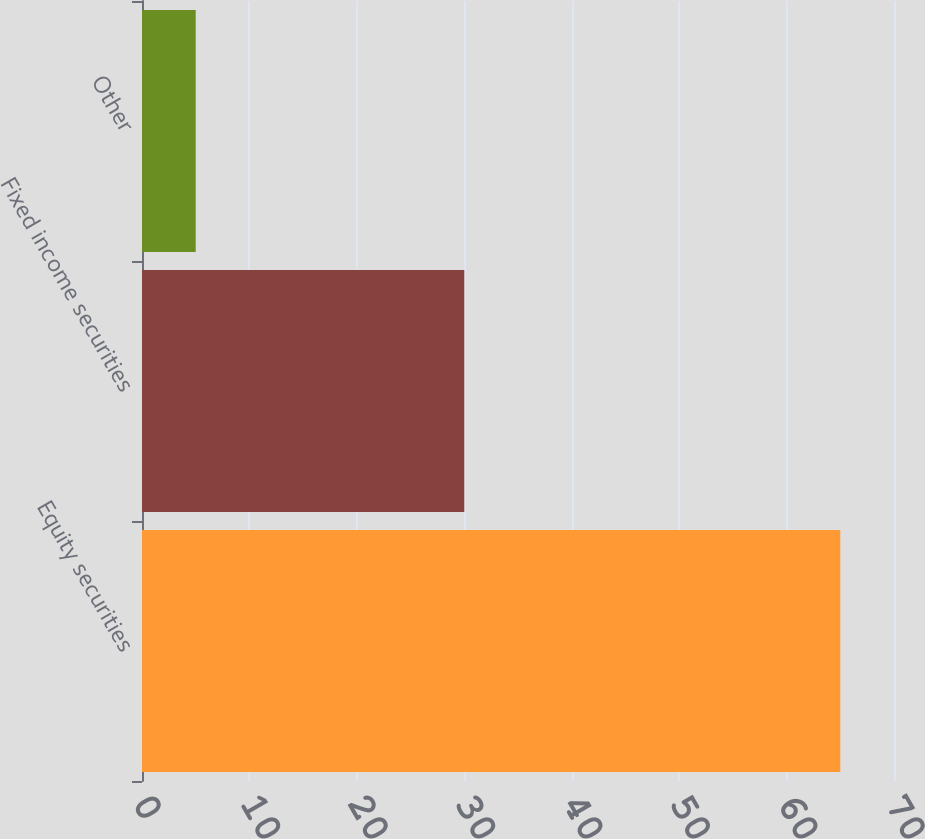<chart> <loc_0><loc_0><loc_500><loc_500><bar_chart><fcel>Equity securities<fcel>Fixed income securities<fcel>Other<nl><fcel>65<fcel>30<fcel>5<nl></chart> 